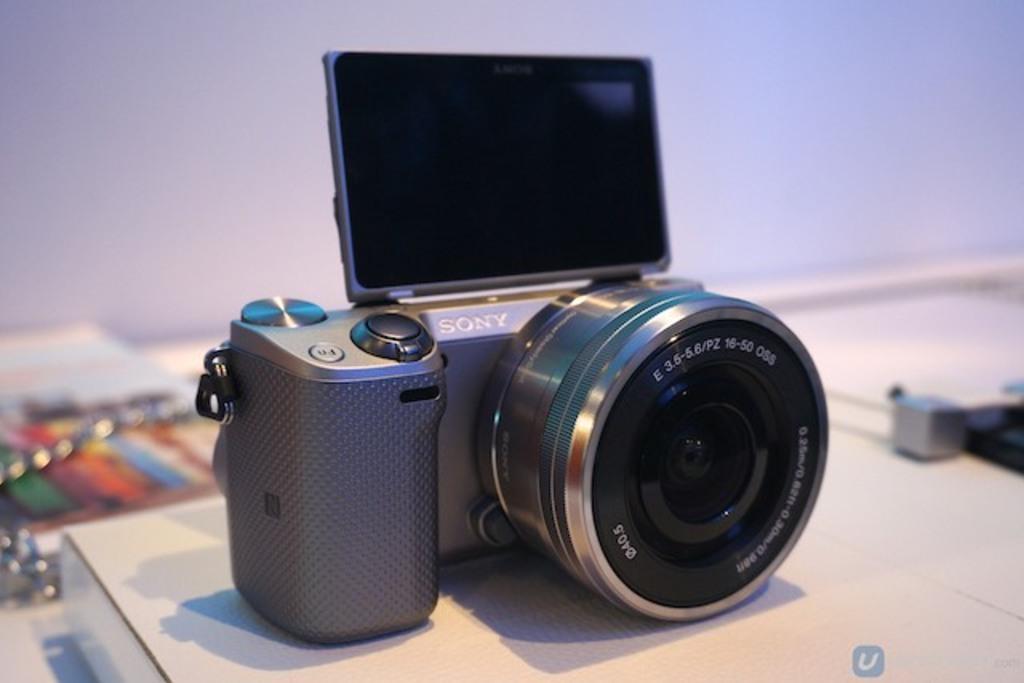Can you describe this image briefly? In this image I can see a camera which is placed on a table. in the background, I can see the wall. 